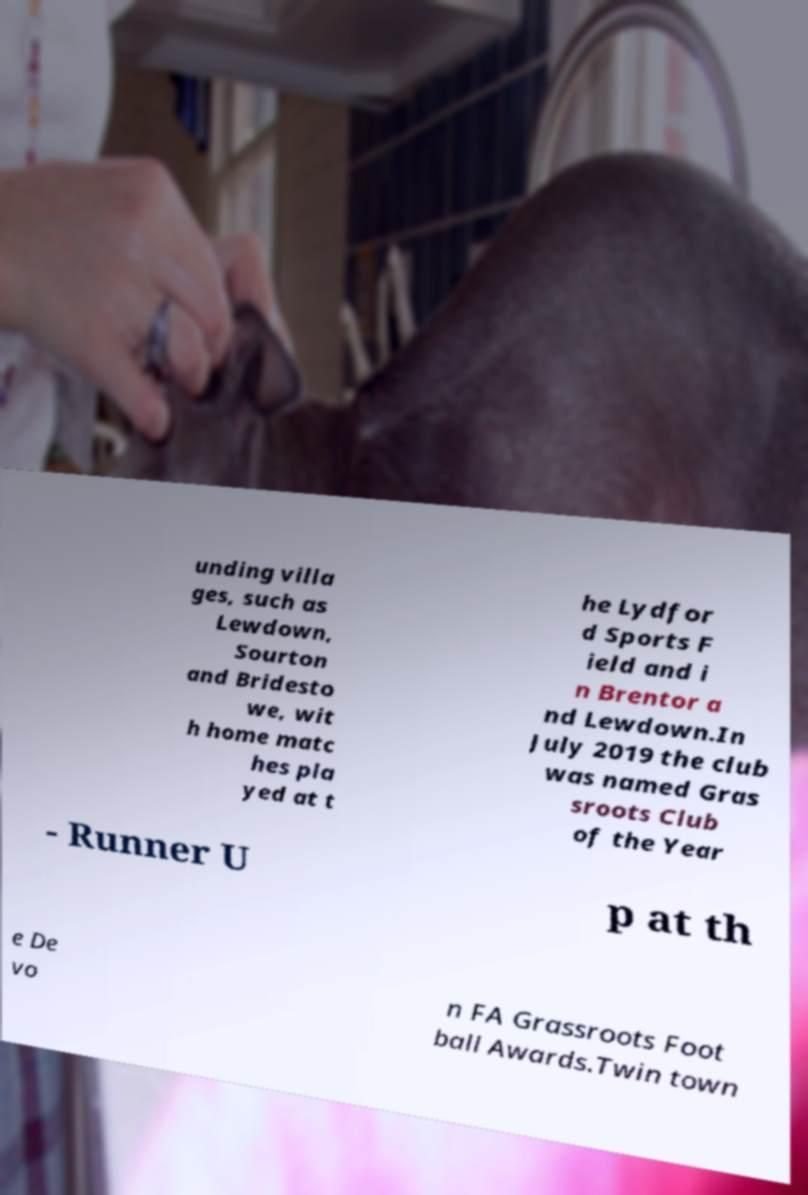For documentation purposes, I need the text within this image transcribed. Could you provide that? unding villa ges, such as Lewdown, Sourton and Bridesto we, wit h home matc hes pla yed at t he Lydfor d Sports F ield and i n Brentor a nd Lewdown.In July 2019 the club was named Gras sroots Club of the Year - Runner U p at th e De vo n FA Grassroots Foot ball Awards.Twin town 